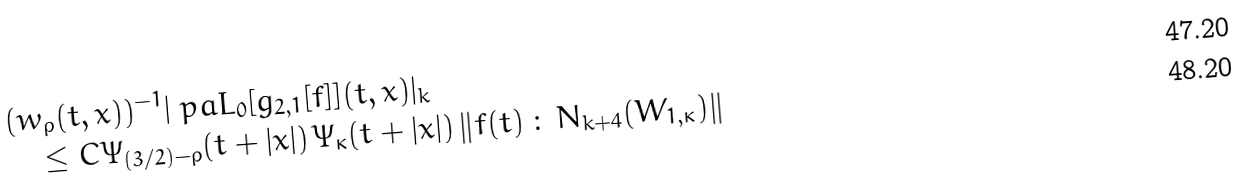Convert formula to latex. <formula><loc_0><loc_0><loc_500><loc_500>& ( w _ { \rho } ( t , x ) ) ^ { - 1 } | \ p a L _ { 0 } [ g _ { 2 , 1 } [ f ] ] ( t , x ) | _ { k } \\ & \quad \leq C \Psi _ { ( 3 / 2 ) - \rho } ( t + | x | ) \, \Psi _ { \kappa } ( t + | x | ) \, \| f ( t ) \, \colon \, { N _ { k + 4 } ( W _ { 1 , \kappa } ) } \|</formula> 